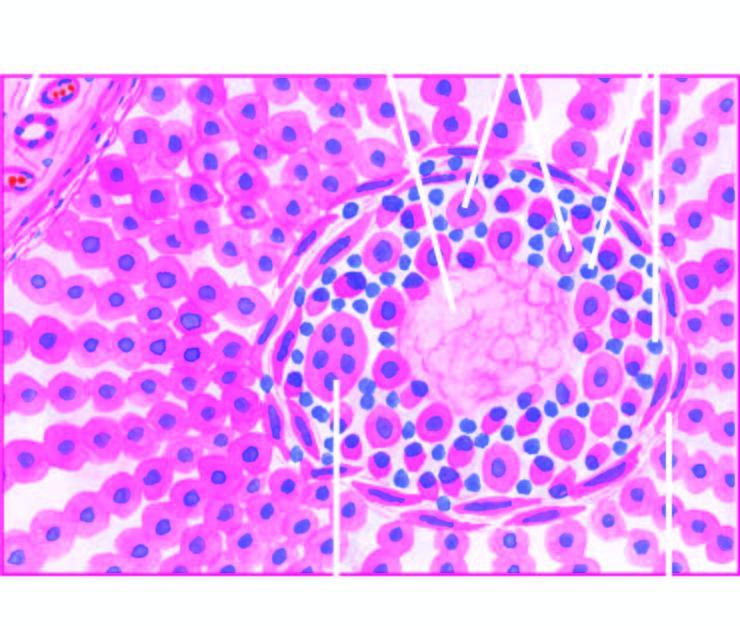s central coagulative necrosis surrounded by palisades of macrophages and plasma cells marginated peripherally by fibroblasts?
Answer the question using a single word or phrase. Yes 